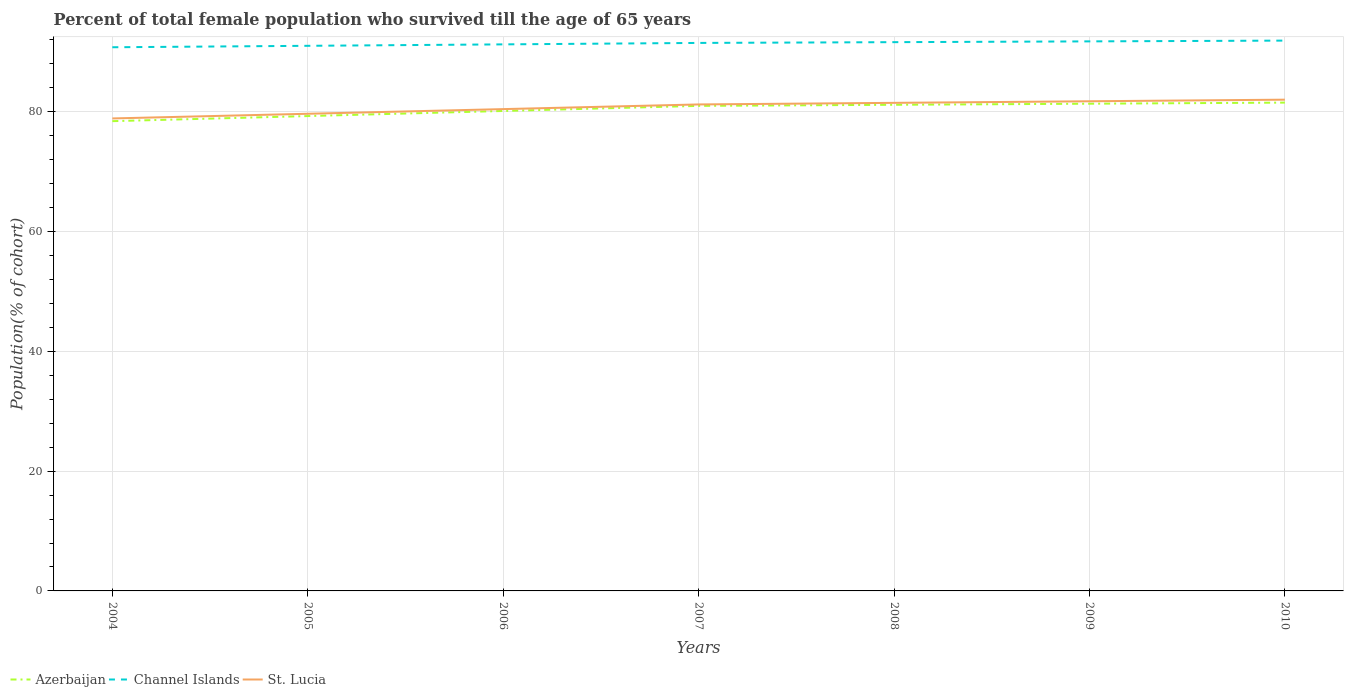Across all years, what is the maximum percentage of total female population who survived till the age of 65 years in Azerbaijan?
Your answer should be very brief. 78.44. In which year was the percentage of total female population who survived till the age of 65 years in Azerbaijan maximum?
Your response must be concise. 2004. What is the total percentage of total female population who survived till the age of 65 years in Azerbaijan in the graph?
Keep it short and to the point. -0.85. What is the difference between the highest and the second highest percentage of total female population who survived till the age of 65 years in St. Lucia?
Your answer should be compact. 3.13. What is the difference between the highest and the lowest percentage of total female population who survived till the age of 65 years in Azerbaijan?
Offer a very short reply. 4. Is the percentage of total female population who survived till the age of 65 years in Channel Islands strictly greater than the percentage of total female population who survived till the age of 65 years in St. Lucia over the years?
Your response must be concise. No. How many lines are there?
Your answer should be very brief. 3. What is the difference between two consecutive major ticks on the Y-axis?
Your answer should be very brief. 20. Where does the legend appear in the graph?
Offer a terse response. Bottom left. How many legend labels are there?
Offer a very short reply. 3. What is the title of the graph?
Offer a terse response. Percent of total female population who survived till the age of 65 years. Does "Macao" appear as one of the legend labels in the graph?
Give a very brief answer. No. What is the label or title of the Y-axis?
Your response must be concise. Population(% of cohort). What is the Population(% of cohort) in Azerbaijan in 2004?
Keep it short and to the point. 78.44. What is the Population(% of cohort) of Channel Islands in 2004?
Your answer should be very brief. 90.79. What is the Population(% of cohort) in St. Lucia in 2004?
Your answer should be compact. 78.9. What is the Population(% of cohort) of Azerbaijan in 2005?
Your response must be concise. 79.3. What is the Population(% of cohort) of Channel Islands in 2005?
Offer a very short reply. 91.03. What is the Population(% of cohort) of St. Lucia in 2005?
Your response must be concise. 79.68. What is the Population(% of cohort) of Azerbaijan in 2006?
Provide a short and direct response. 80.15. What is the Population(% of cohort) in Channel Islands in 2006?
Offer a very short reply. 91.27. What is the Population(% of cohort) of St. Lucia in 2006?
Your response must be concise. 80.46. What is the Population(% of cohort) of Azerbaijan in 2007?
Give a very brief answer. 81. What is the Population(% of cohort) of Channel Islands in 2007?
Your answer should be compact. 91.51. What is the Population(% of cohort) of St. Lucia in 2007?
Your response must be concise. 81.24. What is the Population(% of cohort) of Azerbaijan in 2008?
Make the answer very short. 81.18. What is the Population(% of cohort) in Channel Islands in 2008?
Give a very brief answer. 91.64. What is the Population(% of cohort) in St. Lucia in 2008?
Give a very brief answer. 81.5. What is the Population(% of cohort) in Azerbaijan in 2009?
Provide a short and direct response. 81.36. What is the Population(% of cohort) of Channel Islands in 2009?
Give a very brief answer. 91.77. What is the Population(% of cohort) of St. Lucia in 2009?
Your answer should be very brief. 81.77. What is the Population(% of cohort) in Azerbaijan in 2010?
Ensure brevity in your answer.  81.54. What is the Population(% of cohort) in Channel Islands in 2010?
Provide a short and direct response. 91.9. What is the Population(% of cohort) in St. Lucia in 2010?
Give a very brief answer. 82.03. Across all years, what is the maximum Population(% of cohort) of Azerbaijan?
Your answer should be compact. 81.54. Across all years, what is the maximum Population(% of cohort) in Channel Islands?
Your answer should be compact. 91.9. Across all years, what is the maximum Population(% of cohort) of St. Lucia?
Your answer should be compact. 82.03. Across all years, what is the minimum Population(% of cohort) of Azerbaijan?
Provide a short and direct response. 78.44. Across all years, what is the minimum Population(% of cohort) of Channel Islands?
Ensure brevity in your answer.  90.79. Across all years, what is the minimum Population(% of cohort) in St. Lucia?
Provide a succinct answer. 78.9. What is the total Population(% of cohort) in Azerbaijan in the graph?
Keep it short and to the point. 562.96. What is the total Population(% of cohort) in Channel Islands in the graph?
Your answer should be very brief. 639.89. What is the total Population(% of cohort) in St. Lucia in the graph?
Your response must be concise. 565.57. What is the difference between the Population(% of cohort) of Azerbaijan in 2004 and that in 2005?
Your response must be concise. -0.85. What is the difference between the Population(% of cohort) of Channel Islands in 2004 and that in 2005?
Give a very brief answer. -0.24. What is the difference between the Population(% of cohort) of St. Lucia in 2004 and that in 2005?
Your answer should be compact. -0.78. What is the difference between the Population(% of cohort) of Azerbaijan in 2004 and that in 2006?
Offer a very short reply. -1.7. What is the difference between the Population(% of cohort) in Channel Islands in 2004 and that in 2006?
Make the answer very short. -0.48. What is the difference between the Population(% of cohort) in St. Lucia in 2004 and that in 2006?
Keep it short and to the point. -1.56. What is the difference between the Population(% of cohort) in Azerbaijan in 2004 and that in 2007?
Ensure brevity in your answer.  -2.55. What is the difference between the Population(% of cohort) of Channel Islands in 2004 and that in 2007?
Provide a short and direct response. -0.72. What is the difference between the Population(% of cohort) in St. Lucia in 2004 and that in 2007?
Keep it short and to the point. -2.34. What is the difference between the Population(% of cohort) in Azerbaijan in 2004 and that in 2008?
Keep it short and to the point. -2.73. What is the difference between the Population(% of cohort) of Channel Islands in 2004 and that in 2008?
Make the answer very short. -0.85. What is the difference between the Population(% of cohort) of St. Lucia in 2004 and that in 2008?
Give a very brief answer. -2.6. What is the difference between the Population(% of cohort) of Azerbaijan in 2004 and that in 2009?
Provide a short and direct response. -2.91. What is the difference between the Population(% of cohort) in Channel Islands in 2004 and that in 2009?
Offer a very short reply. -0.98. What is the difference between the Population(% of cohort) in St. Lucia in 2004 and that in 2009?
Offer a very short reply. -2.87. What is the difference between the Population(% of cohort) of Azerbaijan in 2004 and that in 2010?
Ensure brevity in your answer.  -3.1. What is the difference between the Population(% of cohort) in Channel Islands in 2004 and that in 2010?
Your answer should be very brief. -1.11. What is the difference between the Population(% of cohort) in St. Lucia in 2004 and that in 2010?
Your response must be concise. -3.13. What is the difference between the Population(% of cohort) in Azerbaijan in 2005 and that in 2006?
Provide a short and direct response. -0.85. What is the difference between the Population(% of cohort) of Channel Islands in 2005 and that in 2006?
Offer a terse response. -0.24. What is the difference between the Population(% of cohort) of St. Lucia in 2005 and that in 2006?
Provide a short and direct response. -0.78. What is the difference between the Population(% of cohort) in Azerbaijan in 2005 and that in 2007?
Offer a very short reply. -1.7. What is the difference between the Population(% of cohort) of Channel Islands in 2005 and that in 2007?
Offer a very short reply. -0.48. What is the difference between the Population(% of cohort) in St. Lucia in 2005 and that in 2007?
Provide a succinct answer. -1.56. What is the difference between the Population(% of cohort) of Azerbaijan in 2005 and that in 2008?
Your answer should be compact. -1.88. What is the difference between the Population(% of cohort) of Channel Islands in 2005 and that in 2008?
Offer a terse response. -0.61. What is the difference between the Population(% of cohort) in St. Lucia in 2005 and that in 2008?
Provide a succinct answer. -1.82. What is the difference between the Population(% of cohort) of Azerbaijan in 2005 and that in 2009?
Provide a succinct answer. -2.06. What is the difference between the Population(% of cohort) of Channel Islands in 2005 and that in 2009?
Ensure brevity in your answer.  -0.74. What is the difference between the Population(% of cohort) in St. Lucia in 2005 and that in 2009?
Provide a succinct answer. -2.09. What is the difference between the Population(% of cohort) in Azerbaijan in 2005 and that in 2010?
Ensure brevity in your answer.  -2.25. What is the difference between the Population(% of cohort) in Channel Islands in 2005 and that in 2010?
Ensure brevity in your answer.  -0.87. What is the difference between the Population(% of cohort) of St. Lucia in 2005 and that in 2010?
Make the answer very short. -2.35. What is the difference between the Population(% of cohort) in Azerbaijan in 2006 and that in 2007?
Offer a very short reply. -0.85. What is the difference between the Population(% of cohort) in Channel Islands in 2006 and that in 2007?
Give a very brief answer. -0.24. What is the difference between the Population(% of cohort) in St. Lucia in 2006 and that in 2007?
Your answer should be very brief. -0.78. What is the difference between the Population(% of cohort) in Azerbaijan in 2006 and that in 2008?
Your answer should be compact. -1.03. What is the difference between the Population(% of cohort) of Channel Islands in 2006 and that in 2008?
Your answer should be compact. -0.37. What is the difference between the Population(% of cohort) in St. Lucia in 2006 and that in 2008?
Keep it short and to the point. -1.04. What is the difference between the Population(% of cohort) of Azerbaijan in 2006 and that in 2009?
Give a very brief answer. -1.21. What is the difference between the Population(% of cohort) of Channel Islands in 2006 and that in 2009?
Your answer should be very brief. -0.5. What is the difference between the Population(% of cohort) in St. Lucia in 2006 and that in 2009?
Provide a succinct answer. -1.31. What is the difference between the Population(% of cohort) in Azerbaijan in 2006 and that in 2010?
Give a very brief answer. -1.39. What is the difference between the Population(% of cohort) of Channel Islands in 2006 and that in 2010?
Offer a very short reply. -0.63. What is the difference between the Population(% of cohort) in St. Lucia in 2006 and that in 2010?
Give a very brief answer. -1.57. What is the difference between the Population(% of cohort) in Azerbaijan in 2007 and that in 2008?
Offer a terse response. -0.18. What is the difference between the Population(% of cohort) of Channel Islands in 2007 and that in 2008?
Make the answer very short. -0.13. What is the difference between the Population(% of cohort) of St. Lucia in 2007 and that in 2008?
Ensure brevity in your answer.  -0.27. What is the difference between the Population(% of cohort) of Azerbaijan in 2007 and that in 2009?
Your answer should be very brief. -0.36. What is the difference between the Population(% of cohort) of Channel Islands in 2007 and that in 2009?
Provide a succinct answer. -0.26. What is the difference between the Population(% of cohort) in St. Lucia in 2007 and that in 2009?
Provide a short and direct response. -0.53. What is the difference between the Population(% of cohort) of Azerbaijan in 2007 and that in 2010?
Ensure brevity in your answer.  -0.54. What is the difference between the Population(% of cohort) of Channel Islands in 2007 and that in 2010?
Offer a terse response. -0.39. What is the difference between the Population(% of cohort) in St. Lucia in 2007 and that in 2010?
Your response must be concise. -0.8. What is the difference between the Population(% of cohort) in Azerbaijan in 2008 and that in 2009?
Make the answer very short. -0.18. What is the difference between the Population(% of cohort) in Channel Islands in 2008 and that in 2009?
Ensure brevity in your answer.  -0.13. What is the difference between the Population(% of cohort) in St. Lucia in 2008 and that in 2009?
Make the answer very short. -0.27. What is the difference between the Population(% of cohort) of Azerbaijan in 2008 and that in 2010?
Your answer should be very brief. -0.36. What is the difference between the Population(% of cohort) in Channel Islands in 2008 and that in 2010?
Make the answer very short. -0.26. What is the difference between the Population(% of cohort) of St. Lucia in 2008 and that in 2010?
Give a very brief answer. -0.53. What is the difference between the Population(% of cohort) of Azerbaijan in 2009 and that in 2010?
Make the answer very short. -0.18. What is the difference between the Population(% of cohort) in Channel Islands in 2009 and that in 2010?
Make the answer very short. -0.13. What is the difference between the Population(% of cohort) in St. Lucia in 2009 and that in 2010?
Offer a terse response. -0.27. What is the difference between the Population(% of cohort) in Azerbaijan in 2004 and the Population(% of cohort) in Channel Islands in 2005?
Provide a short and direct response. -12.58. What is the difference between the Population(% of cohort) of Azerbaijan in 2004 and the Population(% of cohort) of St. Lucia in 2005?
Make the answer very short. -1.23. What is the difference between the Population(% of cohort) in Channel Islands in 2004 and the Population(% of cohort) in St. Lucia in 2005?
Give a very brief answer. 11.11. What is the difference between the Population(% of cohort) of Azerbaijan in 2004 and the Population(% of cohort) of Channel Islands in 2006?
Keep it short and to the point. -12.82. What is the difference between the Population(% of cohort) of Azerbaijan in 2004 and the Population(% of cohort) of St. Lucia in 2006?
Keep it short and to the point. -2.01. What is the difference between the Population(% of cohort) in Channel Islands in 2004 and the Population(% of cohort) in St. Lucia in 2006?
Your response must be concise. 10.33. What is the difference between the Population(% of cohort) in Azerbaijan in 2004 and the Population(% of cohort) in Channel Islands in 2007?
Offer a terse response. -13.06. What is the difference between the Population(% of cohort) in Azerbaijan in 2004 and the Population(% of cohort) in St. Lucia in 2007?
Make the answer very short. -2.79. What is the difference between the Population(% of cohort) in Channel Islands in 2004 and the Population(% of cohort) in St. Lucia in 2007?
Provide a succinct answer. 9.55. What is the difference between the Population(% of cohort) in Azerbaijan in 2004 and the Population(% of cohort) in Channel Islands in 2008?
Provide a succinct answer. -13.19. What is the difference between the Population(% of cohort) of Azerbaijan in 2004 and the Population(% of cohort) of St. Lucia in 2008?
Give a very brief answer. -3.06. What is the difference between the Population(% of cohort) in Channel Islands in 2004 and the Population(% of cohort) in St. Lucia in 2008?
Provide a short and direct response. 9.28. What is the difference between the Population(% of cohort) of Azerbaijan in 2004 and the Population(% of cohort) of Channel Islands in 2009?
Provide a short and direct response. -13.32. What is the difference between the Population(% of cohort) of Azerbaijan in 2004 and the Population(% of cohort) of St. Lucia in 2009?
Keep it short and to the point. -3.32. What is the difference between the Population(% of cohort) in Channel Islands in 2004 and the Population(% of cohort) in St. Lucia in 2009?
Keep it short and to the point. 9.02. What is the difference between the Population(% of cohort) in Azerbaijan in 2004 and the Population(% of cohort) in Channel Islands in 2010?
Provide a succinct answer. -13.45. What is the difference between the Population(% of cohort) in Azerbaijan in 2004 and the Population(% of cohort) in St. Lucia in 2010?
Keep it short and to the point. -3.59. What is the difference between the Population(% of cohort) in Channel Islands in 2004 and the Population(% of cohort) in St. Lucia in 2010?
Offer a terse response. 8.75. What is the difference between the Population(% of cohort) in Azerbaijan in 2005 and the Population(% of cohort) in Channel Islands in 2006?
Your response must be concise. -11.97. What is the difference between the Population(% of cohort) of Azerbaijan in 2005 and the Population(% of cohort) of St. Lucia in 2006?
Provide a succinct answer. -1.16. What is the difference between the Population(% of cohort) of Channel Islands in 2005 and the Population(% of cohort) of St. Lucia in 2006?
Keep it short and to the point. 10.57. What is the difference between the Population(% of cohort) in Azerbaijan in 2005 and the Population(% of cohort) in Channel Islands in 2007?
Keep it short and to the point. -12.21. What is the difference between the Population(% of cohort) of Azerbaijan in 2005 and the Population(% of cohort) of St. Lucia in 2007?
Offer a very short reply. -1.94. What is the difference between the Population(% of cohort) of Channel Islands in 2005 and the Population(% of cohort) of St. Lucia in 2007?
Offer a terse response. 9.79. What is the difference between the Population(% of cohort) of Azerbaijan in 2005 and the Population(% of cohort) of Channel Islands in 2008?
Offer a terse response. -12.34. What is the difference between the Population(% of cohort) in Azerbaijan in 2005 and the Population(% of cohort) in St. Lucia in 2008?
Your answer should be compact. -2.21. What is the difference between the Population(% of cohort) of Channel Islands in 2005 and the Population(% of cohort) of St. Lucia in 2008?
Provide a short and direct response. 9.52. What is the difference between the Population(% of cohort) of Azerbaijan in 2005 and the Population(% of cohort) of Channel Islands in 2009?
Keep it short and to the point. -12.47. What is the difference between the Population(% of cohort) of Azerbaijan in 2005 and the Population(% of cohort) of St. Lucia in 2009?
Give a very brief answer. -2.47. What is the difference between the Population(% of cohort) in Channel Islands in 2005 and the Population(% of cohort) in St. Lucia in 2009?
Your answer should be very brief. 9.26. What is the difference between the Population(% of cohort) in Azerbaijan in 2005 and the Population(% of cohort) in Channel Islands in 2010?
Ensure brevity in your answer.  -12.6. What is the difference between the Population(% of cohort) in Azerbaijan in 2005 and the Population(% of cohort) in St. Lucia in 2010?
Make the answer very short. -2.74. What is the difference between the Population(% of cohort) of Channel Islands in 2005 and the Population(% of cohort) of St. Lucia in 2010?
Offer a terse response. 8.99. What is the difference between the Population(% of cohort) of Azerbaijan in 2006 and the Population(% of cohort) of Channel Islands in 2007?
Provide a short and direct response. -11.36. What is the difference between the Population(% of cohort) of Azerbaijan in 2006 and the Population(% of cohort) of St. Lucia in 2007?
Your answer should be very brief. -1.09. What is the difference between the Population(% of cohort) in Channel Islands in 2006 and the Population(% of cohort) in St. Lucia in 2007?
Offer a terse response. 10.03. What is the difference between the Population(% of cohort) in Azerbaijan in 2006 and the Population(% of cohort) in Channel Islands in 2008?
Ensure brevity in your answer.  -11.49. What is the difference between the Population(% of cohort) in Azerbaijan in 2006 and the Population(% of cohort) in St. Lucia in 2008?
Keep it short and to the point. -1.36. What is the difference between the Population(% of cohort) of Channel Islands in 2006 and the Population(% of cohort) of St. Lucia in 2008?
Provide a succinct answer. 9.77. What is the difference between the Population(% of cohort) of Azerbaijan in 2006 and the Population(% of cohort) of Channel Islands in 2009?
Offer a terse response. -11.62. What is the difference between the Population(% of cohort) in Azerbaijan in 2006 and the Population(% of cohort) in St. Lucia in 2009?
Provide a succinct answer. -1.62. What is the difference between the Population(% of cohort) in Channel Islands in 2006 and the Population(% of cohort) in St. Lucia in 2009?
Keep it short and to the point. 9.5. What is the difference between the Population(% of cohort) of Azerbaijan in 2006 and the Population(% of cohort) of Channel Islands in 2010?
Give a very brief answer. -11.75. What is the difference between the Population(% of cohort) of Azerbaijan in 2006 and the Population(% of cohort) of St. Lucia in 2010?
Provide a succinct answer. -1.89. What is the difference between the Population(% of cohort) in Channel Islands in 2006 and the Population(% of cohort) in St. Lucia in 2010?
Your answer should be compact. 9.24. What is the difference between the Population(% of cohort) of Azerbaijan in 2007 and the Population(% of cohort) of Channel Islands in 2008?
Offer a very short reply. -10.64. What is the difference between the Population(% of cohort) of Azerbaijan in 2007 and the Population(% of cohort) of St. Lucia in 2008?
Your answer should be very brief. -0.5. What is the difference between the Population(% of cohort) of Channel Islands in 2007 and the Population(% of cohort) of St. Lucia in 2008?
Offer a terse response. 10.01. What is the difference between the Population(% of cohort) in Azerbaijan in 2007 and the Population(% of cohort) in Channel Islands in 2009?
Your answer should be very brief. -10.77. What is the difference between the Population(% of cohort) in Azerbaijan in 2007 and the Population(% of cohort) in St. Lucia in 2009?
Provide a short and direct response. -0.77. What is the difference between the Population(% of cohort) of Channel Islands in 2007 and the Population(% of cohort) of St. Lucia in 2009?
Your answer should be very brief. 9.74. What is the difference between the Population(% of cohort) of Azerbaijan in 2007 and the Population(% of cohort) of Channel Islands in 2010?
Your answer should be compact. -10.9. What is the difference between the Population(% of cohort) of Azerbaijan in 2007 and the Population(% of cohort) of St. Lucia in 2010?
Offer a very short reply. -1.03. What is the difference between the Population(% of cohort) in Channel Islands in 2007 and the Population(% of cohort) in St. Lucia in 2010?
Offer a very short reply. 9.48. What is the difference between the Population(% of cohort) of Azerbaijan in 2008 and the Population(% of cohort) of Channel Islands in 2009?
Keep it short and to the point. -10.59. What is the difference between the Population(% of cohort) of Azerbaijan in 2008 and the Population(% of cohort) of St. Lucia in 2009?
Offer a terse response. -0.59. What is the difference between the Population(% of cohort) of Channel Islands in 2008 and the Population(% of cohort) of St. Lucia in 2009?
Your answer should be compact. 9.87. What is the difference between the Population(% of cohort) of Azerbaijan in 2008 and the Population(% of cohort) of Channel Islands in 2010?
Provide a succinct answer. -10.72. What is the difference between the Population(% of cohort) in Azerbaijan in 2008 and the Population(% of cohort) in St. Lucia in 2010?
Offer a terse response. -0.85. What is the difference between the Population(% of cohort) of Channel Islands in 2008 and the Population(% of cohort) of St. Lucia in 2010?
Offer a terse response. 9.61. What is the difference between the Population(% of cohort) in Azerbaijan in 2009 and the Population(% of cohort) in Channel Islands in 2010?
Keep it short and to the point. -10.54. What is the difference between the Population(% of cohort) in Azerbaijan in 2009 and the Population(% of cohort) in St. Lucia in 2010?
Keep it short and to the point. -0.67. What is the difference between the Population(% of cohort) in Channel Islands in 2009 and the Population(% of cohort) in St. Lucia in 2010?
Provide a short and direct response. 9.73. What is the average Population(% of cohort) of Azerbaijan per year?
Your response must be concise. 80.42. What is the average Population(% of cohort) of Channel Islands per year?
Keep it short and to the point. 91.41. What is the average Population(% of cohort) of St. Lucia per year?
Your answer should be compact. 80.8. In the year 2004, what is the difference between the Population(% of cohort) of Azerbaijan and Population(% of cohort) of Channel Islands?
Give a very brief answer. -12.34. In the year 2004, what is the difference between the Population(% of cohort) in Azerbaijan and Population(% of cohort) in St. Lucia?
Your answer should be very brief. -0.45. In the year 2004, what is the difference between the Population(% of cohort) of Channel Islands and Population(% of cohort) of St. Lucia?
Keep it short and to the point. 11.89. In the year 2005, what is the difference between the Population(% of cohort) of Azerbaijan and Population(% of cohort) of Channel Islands?
Provide a succinct answer. -11.73. In the year 2005, what is the difference between the Population(% of cohort) of Azerbaijan and Population(% of cohort) of St. Lucia?
Offer a terse response. -0.38. In the year 2005, what is the difference between the Population(% of cohort) of Channel Islands and Population(% of cohort) of St. Lucia?
Provide a succinct answer. 11.35. In the year 2006, what is the difference between the Population(% of cohort) of Azerbaijan and Population(% of cohort) of Channel Islands?
Keep it short and to the point. -11.12. In the year 2006, what is the difference between the Population(% of cohort) of Azerbaijan and Population(% of cohort) of St. Lucia?
Your response must be concise. -0.31. In the year 2006, what is the difference between the Population(% of cohort) of Channel Islands and Population(% of cohort) of St. Lucia?
Provide a short and direct response. 10.81. In the year 2007, what is the difference between the Population(% of cohort) of Azerbaijan and Population(% of cohort) of Channel Islands?
Make the answer very short. -10.51. In the year 2007, what is the difference between the Population(% of cohort) of Azerbaijan and Population(% of cohort) of St. Lucia?
Give a very brief answer. -0.24. In the year 2007, what is the difference between the Population(% of cohort) in Channel Islands and Population(% of cohort) in St. Lucia?
Ensure brevity in your answer.  10.27. In the year 2008, what is the difference between the Population(% of cohort) of Azerbaijan and Population(% of cohort) of Channel Islands?
Ensure brevity in your answer.  -10.46. In the year 2008, what is the difference between the Population(% of cohort) of Azerbaijan and Population(% of cohort) of St. Lucia?
Make the answer very short. -0.32. In the year 2008, what is the difference between the Population(% of cohort) in Channel Islands and Population(% of cohort) in St. Lucia?
Provide a succinct answer. 10.14. In the year 2009, what is the difference between the Population(% of cohort) in Azerbaijan and Population(% of cohort) in Channel Islands?
Keep it short and to the point. -10.41. In the year 2009, what is the difference between the Population(% of cohort) in Azerbaijan and Population(% of cohort) in St. Lucia?
Your response must be concise. -0.41. In the year 2009, what is the difference between the Population(% of cohort) in Channel Islands and Population(% of cohort) in St. Lucia?
Provide a succinct answer. 10. In the year 2010, what is the difference between the Population(% of cohort) in Azerbaijan and Population(% of cohort) in Channel Islands?
Make the answer very short. -10.36. In the year 2010, what is the difference between the Population(% of cohort) of Azerbaijan and Population(% of cohort) of St. Lucia?
Give a very brief answer. -0.49. In the year 2010, what is the difference between the Population(% of cohort) of Channel Islands and Population(% of cohort) of St. Lucia?
Make the answer very short. 9.86. What is the ratio of the Population(% of cohort) of Azerbaijan in 2004 to that in 2005?
Keep it short and to the point. 0.99. What is the ratio of the Population(% of cohort) in St. Lucia in 2004 to that in 2005?
Provide a succinct answer. 0.99. What is the ratio of the Population(% of cohort) of Azerbaijan in 2004 to that in 2006?
Give a very brief answer. 0.98. What is the ratio of the Population(% of cohort) of Channel Islands in 2004 to that in 2006?
Offer a very short reply. 0.99. What is the ratio of the Population(% of cohort) of St. Lucia in 2004 to that in 2006?
Keep it short and to the point. 0.98. What is the ratio of the Population(% of cohort) of Azerbaijan in 2004 to that in 2007?
Ensure brevity in your answer.  0.97. What is the ratio of the Population(% of cohort) of St. Lucia in 2004 to that in 2007?
Offer a terse response. 0.97. What is the ratio of the Population(% of cohort) in Azerbaijan in 2004 to that in 2008?
Make the answer very short. 0.97. What is the ratio of the Population(% of cohort) of St. Lucia in 2004 to that in 2008?
Give a very brief answer. 0.97. What is the ratio of the Population(% of cohort) of Azerbaijan in 2004 to that in 2009?
Offer a very short reply. 0.96. What is the ratio of the Population(% of cohort) in Channel Islands in 2004 to that in 2009?
Offer a terse response. 0.99. What is the ratio of the Population(% of cohort) in St. Lucia in 2004 to that in 2009?
Provide a succinct answer. 0.96. What is the ratio of the Population(% of cohort) of Azerbaijan in 2004 to that in 2010?
Your response must be concise. 0.96. What is the ratio of the Population(% of cohort) of Channel Islands in 2004 to that in 2010?
Your answer should be very brief. 0.99. What is the ratio of the Population(% of cohort) in St. Lucia in 2004 to that in 2010?
Your answer should be very brief. 0.96. What is the ratio of the Population(% of cohort) in St. Lucia in 2005 to that in 2006?
Provide a short and direct response. 0.99. What is the ratio of the Population(% of cohort) of Azerbaijan in 2005 to that in 2007?
Keep it short and to the point. 0.98. What is the ratio of the Population(% of cohort) in St. Lucia in 2005 to that in 2007?
Your answer should be compact. 0.98. What is the ratio of the Population(% of cohort) in Azerbaijan in 2005 to that in 2008?
Your answer should be compact. 0.98. What is the ratio of the Population(% of cohort) of St. Lucia in 2005 to that in 2008?
Ensure brevity in your answer.  0.98. What is the ratio of the Population(% of cohort) of Azerbaijan in 2005 to that in 2009?
Make the answer very short. 0.97. What is the ratio of the Population(% of cohort) of St. Lucia in 2005 to that in 2009?
Keep it short and to the point. 0.97. What is the ratio of the Population(% of cohort) of Azerbaijan in 2005 to that in 2010?
Provide a succinct answer. 0.97. What is the ratio of the Population(% of cohort) in Channel Islands in 2005 to that in 2010?
Provide a short and direct response. 0.99. What is the ratio of the Population(% of cohort) of St. Lucia in 2005 to that in 2010?
Offer a very short reply. 0.97. What is the ratio of the Population(% of cohort) of Azerbaijan in 2006 to that in 2008?
Give a very brief answer. 0.99. What is the ratio of the Population(% of cohort) in Channel Islands in 2006 to that in 2008?
Provide a short and direct response. 1. What is the ratio of the Population(% of cohort) in St. Lucia in 2006 to that in 2008?
Keep it short and to the point. 0.99. What is the ratio of the Population(% of cohort) of Azerbaijan in 2006 to that in 2009?
Make the answer very short. 0.99. What is the ratio of the Population(% of cohort) of Channel Islands in 2006 to that in 2009?
Your answer should be very brief. 0.99. What is the ratio of the Population(% of cohort) in St. Lucia in 2006 to that in 2009?
Make the answer very short. 0.98. What is the ratio of the Population(% of cohort) in Azerbaijan in 2006 to that in 2010?
Provide a short and direct response. 0.98. What is the ratio of the Population(% of cohort) in St. Lucia in 2006 to that in 2010?
Offer a very short reply. 0.98. What is the ratio of the Population(% of cohort) in Azerbaijan in 2007 to that in 2009?
Make the answer very short. 1. What is the ratio of the Population(% of cohort) of Channel Islands in 2007 to that in 2009?
Offer a very short reply. 1. What is the ratio of the Population(% of cohort) in St. Lucia in 2007 to that in 2010?
Your answer should be compact. 0.99. What is the ratio of the Population(% of cohort) of Azerbaijan in 2008 to that in 2009?
Give a very brief answer. 1. What is the ratio of the Population(% of cohort) in St. Lucia in 2008 to that in 2009?
Ensure brevity in your answer.  1. What is the ratio of the Population(% of cohort) of Azerbaijan in 2008 to that in 2010?
Ensure brevity in your answer.  1. What is the ratio of the Population(% of cohort) in Channel Islands in 2008 to that in 2010?
Give a very brief answer. 1. What is the ratio of the Population(% of cohort) of St. Lucia in 2008 to that in 2010?
Your answer should be very brief. 0.99. What is the ratio of the Population(% of cohort) in St. Lucia in 2009 to that in 2010?
Ensure brevity in your answer.  1. What is the difference between the highest and the second highest Population(% of cohort) of Azerbaijan?
Give a very brief answer. 0.18. What is the difference between the highest and the second highest Population(% of cohort) in Channel Islands?
Your answer should be very brief. 0.13. What is the difference between the highest and the second highest Population(% of cohort) in St. Lucia?
Keep it short and to the point. 0.27. What is the difference between the highest and the lowest Population(% of cohort) of Azerbaijan?
Keep it short and to the point. 3.1. What is the difference between the highest and the lowest Population(% of cohort) of Channel Islands?
Keep it short and to the point. 1.11. What is the difference between the highest and the lowest Population(% of cohort) in St. Lucia?
Give a very brief answer. 3.13. 